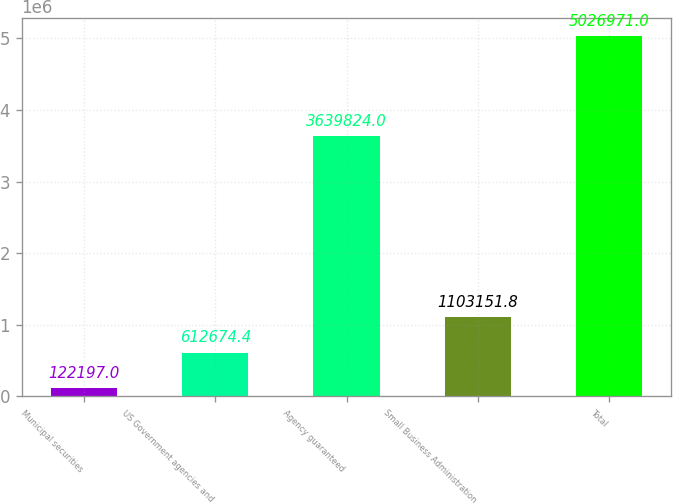Convert chart to OTSL. <chart><loc_0><loc_0><loc_500><loc_500><bar_chart><fcel>Municipal securities<fcel>US Government agencies and<fcel>Agency guaranteed<fcel>Small Business Administration<fcel>Total<nl><fcel>122197<fcel>612674<fcel>3.63982e+06<fcel>1.10315e+06<fcel>5.02697e+06<nl></chart> 